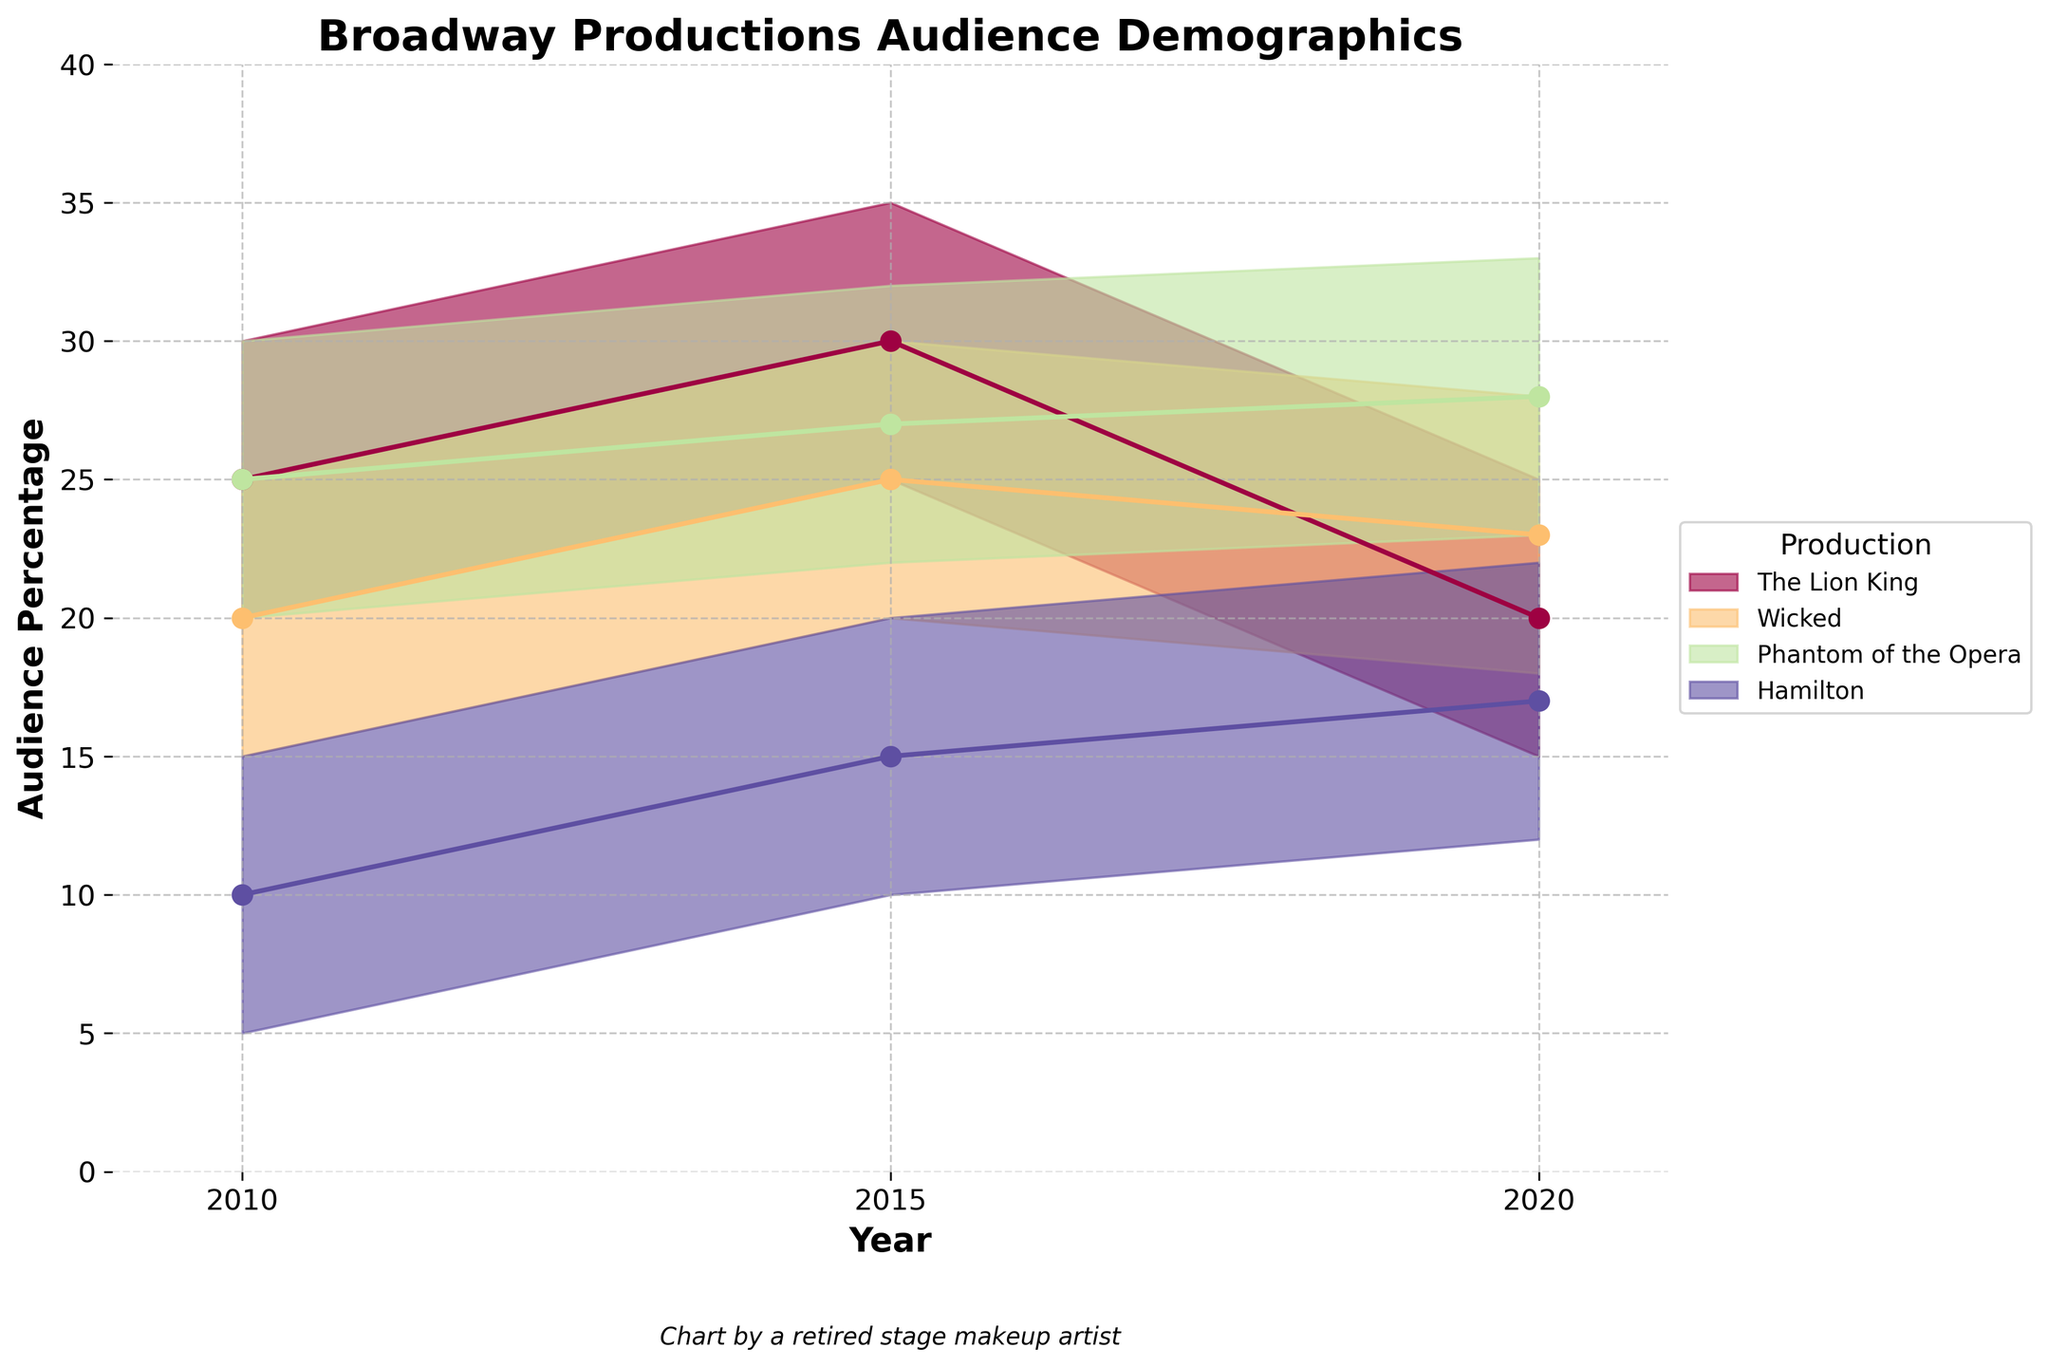What is the title of the figure? The title of the figure is located at the top center and generally provides a concise description of what the chart represents. In this case, it specifies the subject of the chart.
Answer: Broadway Productions Audience Demographics Which production had the highest upper percentage for the year 2010? To determine this, we look at the highest upper boundary (y-axis value) for each production in 2010. By comparing the values, we can identify the production with the highest number.
Answer: The Lion King What is the average percentage range for Hamilton in 2015? To calculate the average percentage range, we take the lower percentage and upper percentage for Hamilton in 2015, add them, and then divide by two. The values are (10 + 20) / 2.
Answer: 15 Which production's audience demographic displayed the most consistency over the years? Consistency can be interpreted as having the smallest changes in the percentage range over the years. By examining the changes for each production, we can identify which one had relatively stable values.
Answer: Phantom of the Opera In which year did Wicked have a higher lower percentage compared to Hamilton's upper percentage? We compare Wicked's lower percentage with Hamilton's upper percentage year by year. From the values in 2015 (20 vs. 20) and 2020 (18 vs. 22), we see that only in 2015 was Wicked's lower percentage equal to one of Hamilton's upper percentages.
Answer: None Which production had the largest increase in its upper percentage from 2010 to 2015? To find the largest increase, we subtract the upper percentage in 2010 from the upper percentage in 2015 for each production and compare the results. Here, we calculate (35-30) for The Lion King, (30-25) for Wicked, (32-30) for Phantom of the Opera, and (20-15) for Hamilton.
Answer: Wicked What is the median upper percentage of all productions in 2020? The median is the middle value when the numbers are arranged in ascending order. The upper percentage values for all productions in 2020 are 25, 28, 33, and 22. Arranged, they are 22, 25, 28, and 33. The median is the average of the two middle values: (25+28)/2.
Answer: 26.5 Did any production show a decrease in their lower percentage from 2010 to 2020? We compare the lower percentage values for each production in 2010 and 2020. The Lion King (20 to 15), Wicked (15 to 18), Phantom of the Opera (20 to 23), and Hamilton (5 to 12). Only The Lion King had a decrease from 20 to 15.
Answer: Yes, The Lion King Which production had the narrowest percentage range in 2020? The percentage range is determined by subtracting the lower percentage from the upper percentage. In 2020, the ranges are The Lion King (25-15=10), Wicked (28-18=10), Phantom of the Opera (33-23=10), and Hamilton (22-12=10). All productions have the same range.
Answer: All had the same range In which year did The Lion King have the smallest percentage range? The range is calculated by subtracting the lower percentage from the upper percentage for each year and then comparing the values. For The Lion King: 2010 (30-20=10), 2015 (35-25=10), and 2020 (25-15=10). The values are the same for all years.
Answer: All years had the same range 